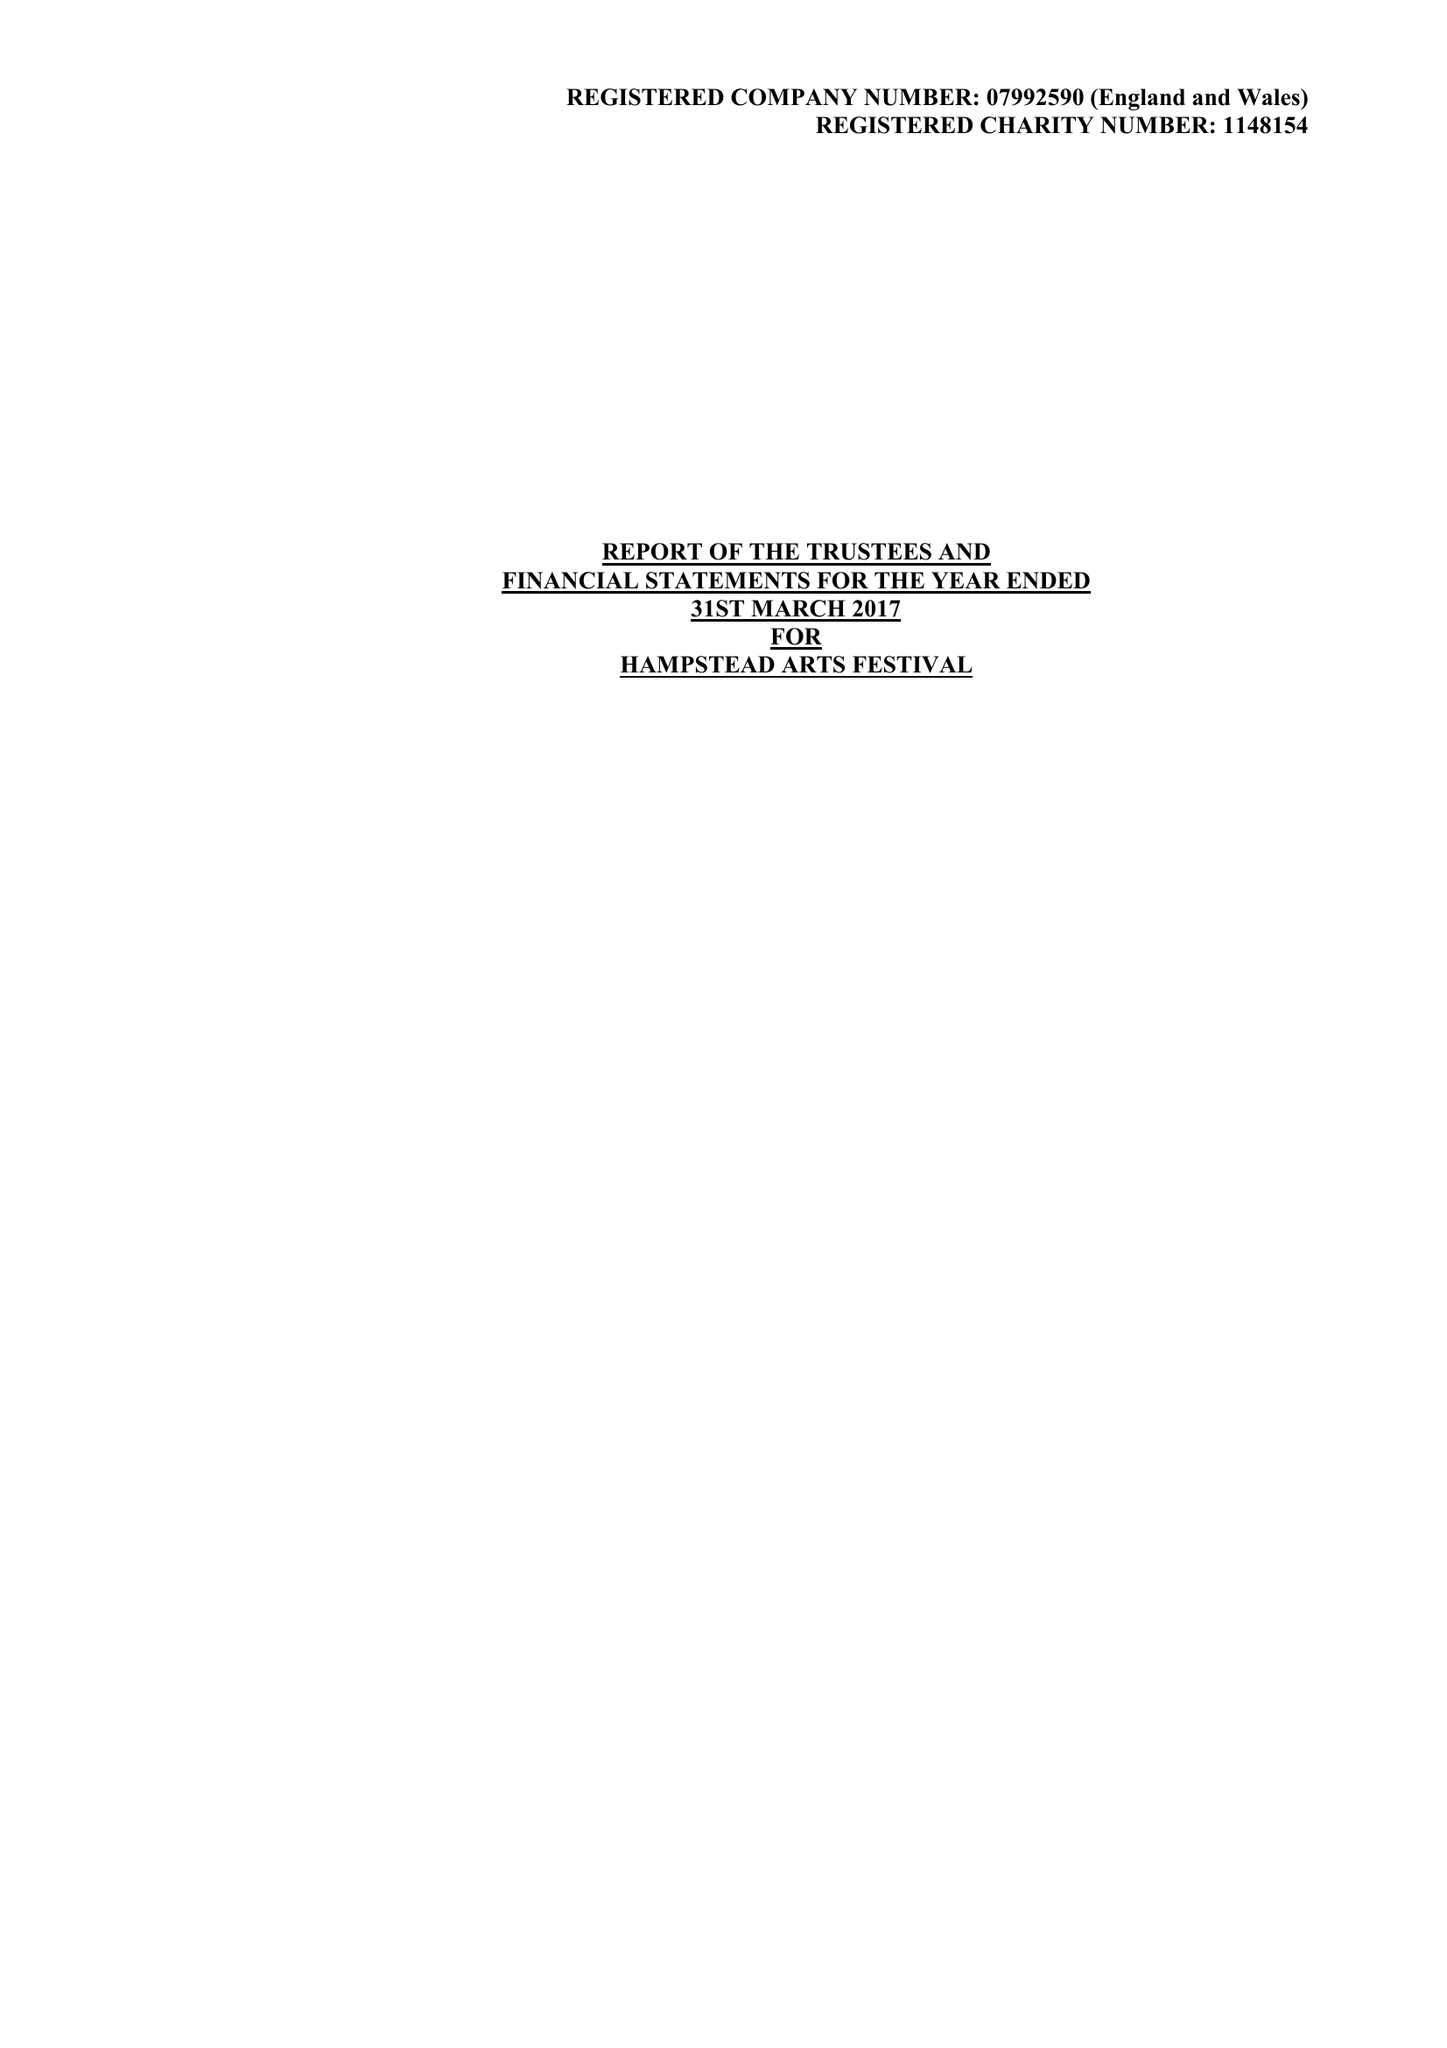What is the value for the charity_name?
Answer the question using a single word or phrase. Hampstead Arts Festival 